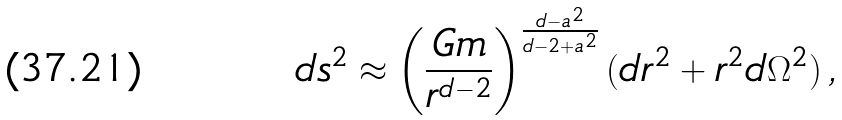Convert formula to latex. <formula><loc_0><loc_0><loc_500><loc_500>d s ^ { 2 } \approx \left ( \frac { G m } { r ^ { d - 2 } } \right ) ^ { \frac { d - a ^ { 2 } } { d - 2 + a ^ { 2 } } } ( d r ^ { 2 } + r ^ { 2 } d \Omega ^ { 2 } ) \, ,</formula> 